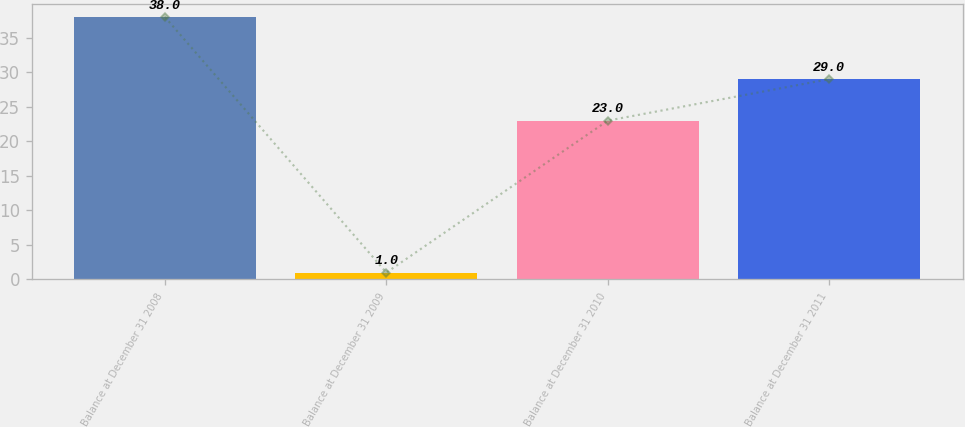Convert chart. <chart><loc_0><loc_0><loc_500><loc_500><bar_chart><fcel>Balance at December 31 2008<fcel>Balance at December 31 2009<fcel>Balance at December 31 2010<fcel>Balance at December 31 2011<nl><fcel>38<fcel>1<fcel>23<fcel>29<nl></chart> 